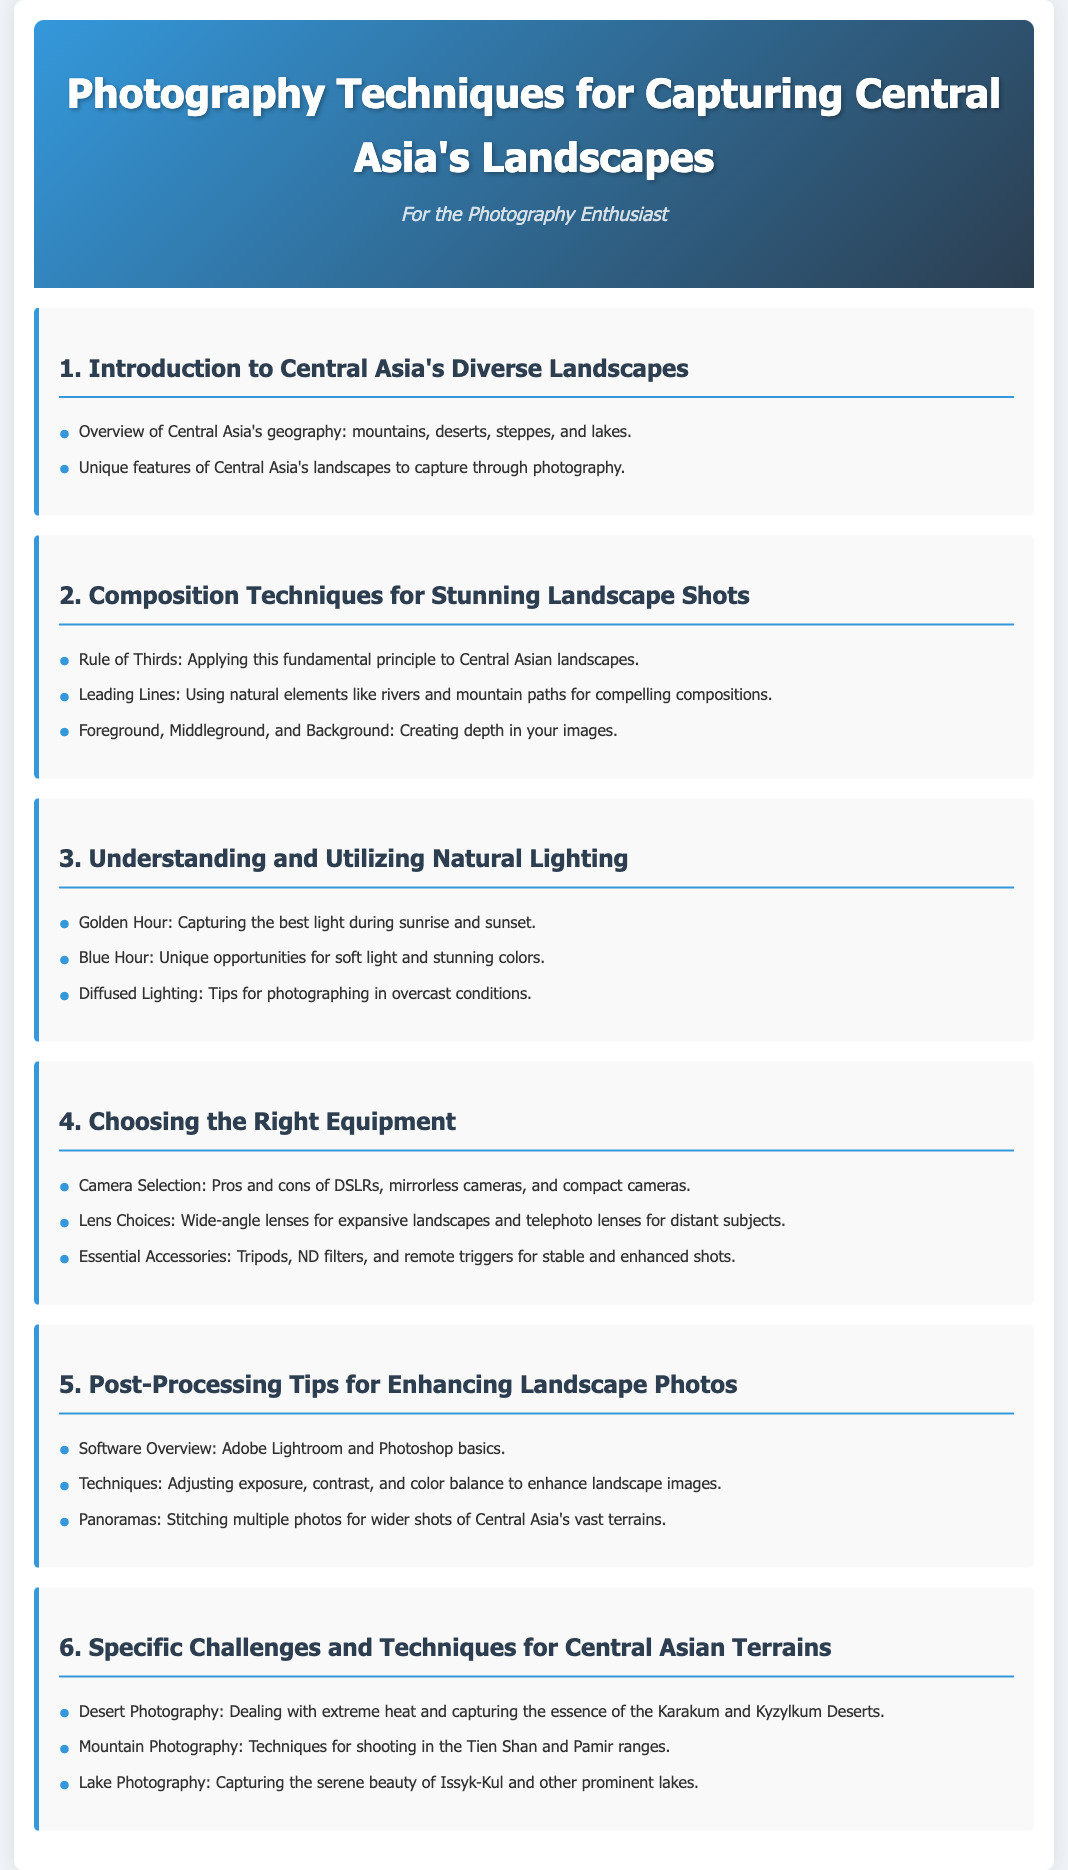What are the unique features of Central Asia's landscapes? The document lists unique features to capture through photography as part of the introduction.
Answer: Unique features What is the focus of the second module? The second module addresses composition techniques specifically for landscape shots.
Answer: Composition Techniques What lighting conditions are highlighted for photography? The document discusses natural lighting conditions like golden hour, blue hour, and diffused lighting.
Answer: Golden Hour, Blue Hour, Diffused Lighting What type of camera is mentioned as a selection option? The document lists DSLRs, mirrorless cameras, and compact cameras as camera selection options.
Answer: DSLRs, mirrorless cameras, compact cameras Which lens type is recommended for expansive landscapes? The document suggests using wide-angle lenses in the equipment choosing section.
Answer: Wide-angle lenses What is a common challenge for desert photography mentioned? The document indicates extreme heat as a challenge in desert photography.
Answer: Extreme heat What software is recommended for post-processing? Adobe Lightroom and Photoshop are mentioned in the post-processing tips section.
Answer: Adobe Lightroom, Photoshop How many modules are focused on specific challenges and techniques for terrains? There is one module that discusses specific challenges and techniques for Central Asian terrains.
Answer: One module 